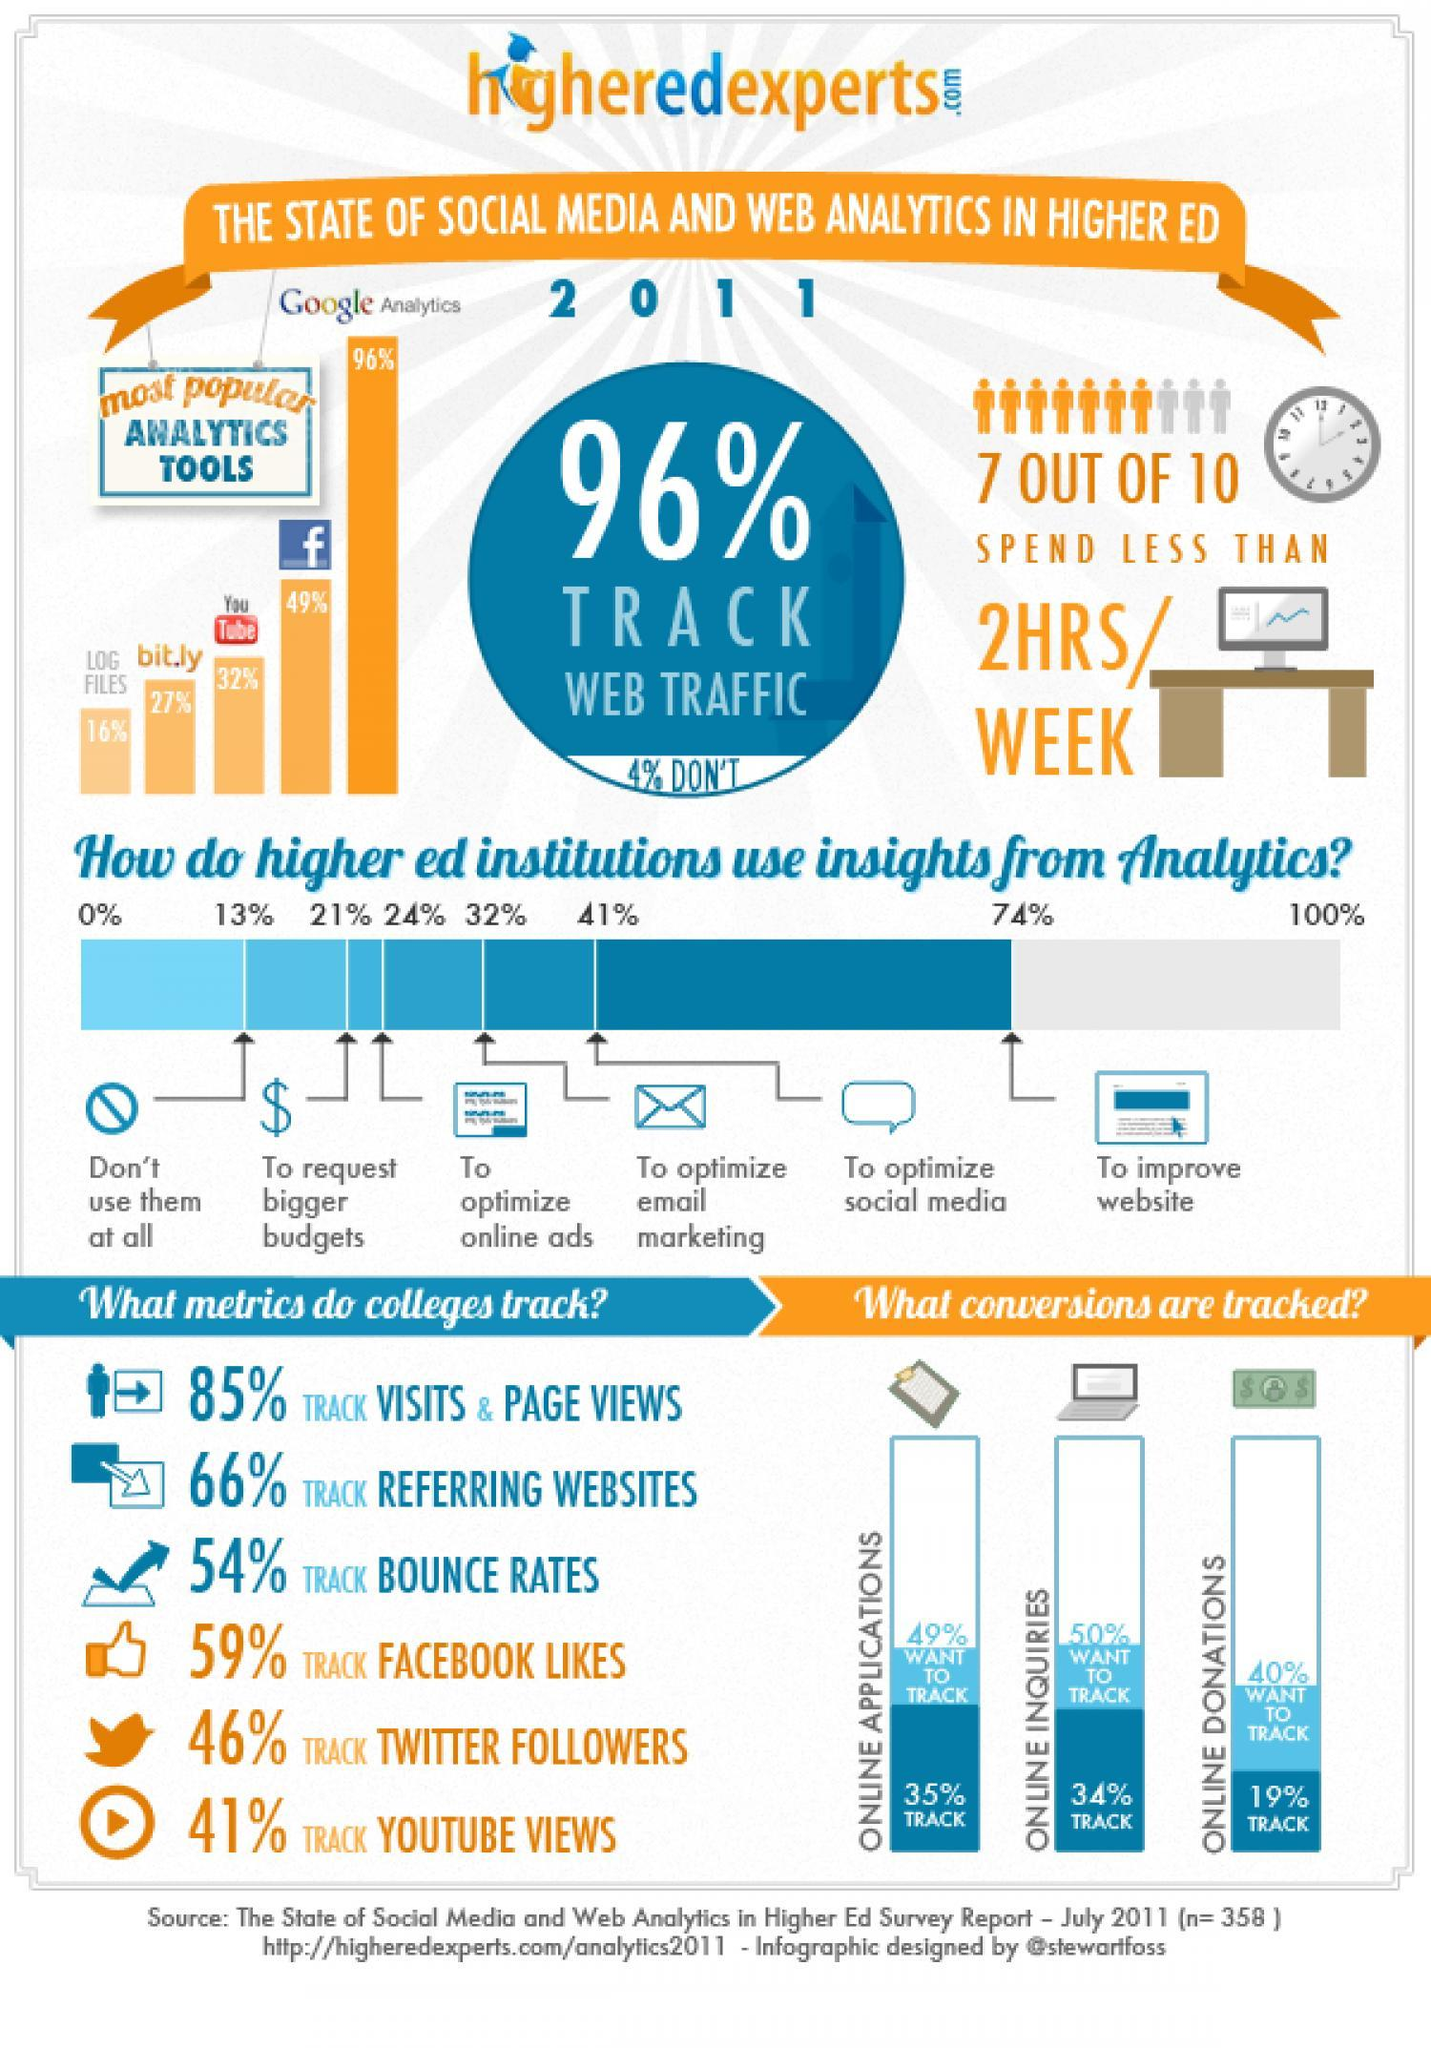What percentage use Log files and bit.ly as analytics tools?
Answer the question with a short phrase. 43% What percentage of online enquires tracked? 34% What percentage use Facebook and Youtube as analytics tools? 81% What percentage of online donations tracked? 19% What percentage use web traffic to track? 96% 